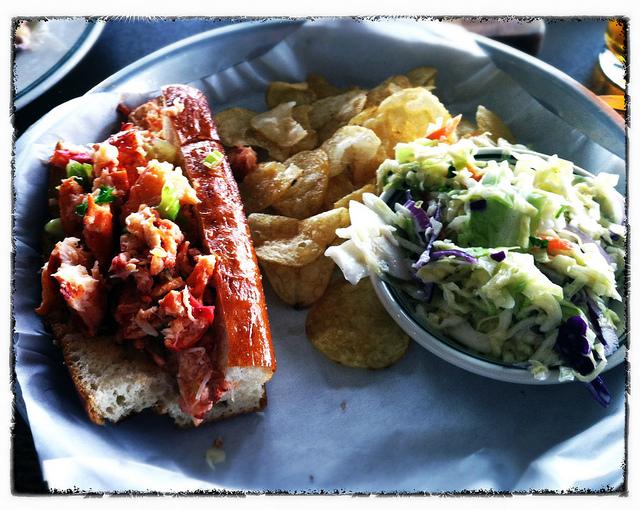What color is the plate?
Short answer required. White. What is in the small round dish on the plate?
Be succinct. Salad. Has the food been eaten at all?
Write a very short answer. Yes. 